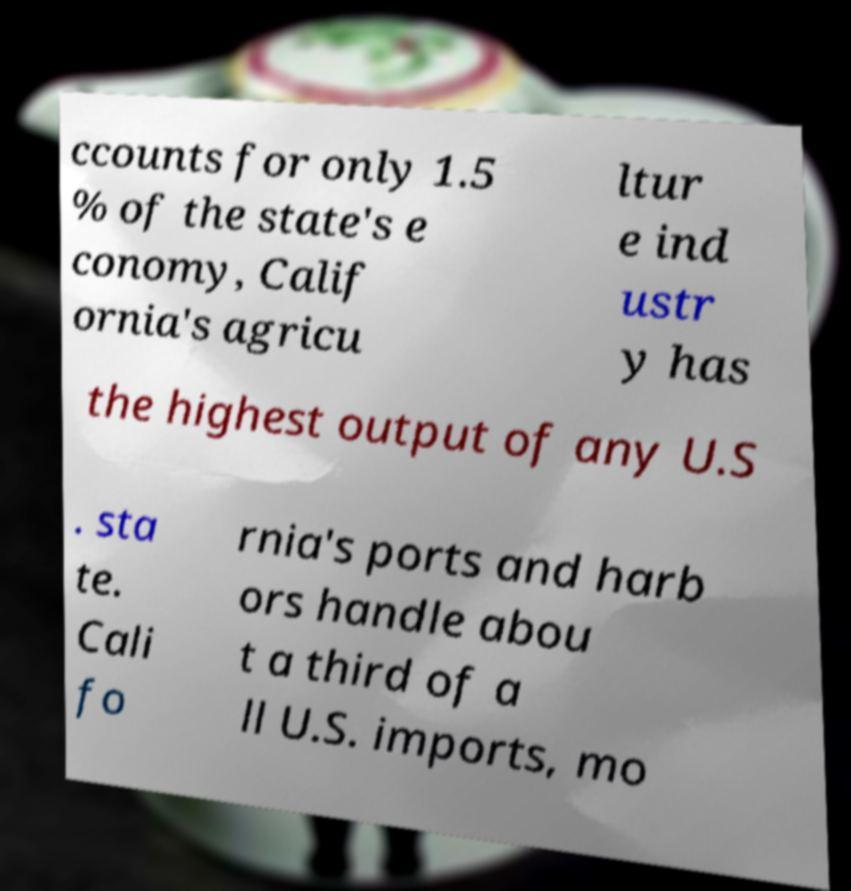For documentation purposes, I need the text within this image transcribed. Could you provide that? ccounts for only 1.5 % of the state's e conomy, Calif ornia's agricu ltur e ind ustr y has the highest output of any U.S . sta te. Cali fo rnia's ports and harb ors handle abou t a third of a ll U.S. imports, mo 